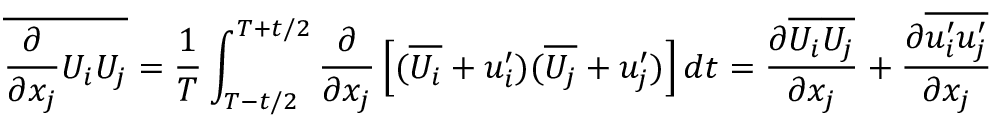Convert formula to latex. <formula><loc_0><loc_0><loc_500><loc_500>\overline { { { \frac { \partial } { \partial x _ { j } } } U _ { i } U _ { j } } } = { \frac { 1 } { T } } \int _ { T - t / 2 } ^ { T + t / 2 } { \frac { \partial } { \partial x _ { j } } } \left [ ( \overline { { U _ { i } } } + u _ { i } ^ { \prime } ) ( \overline { { U _ { j } } } + u _ { j } ^ { \prime } ) \right ] d t = { \frac { \partial \overline { { U _ { i } } } \overline { { U _ { j } } } } { \partial x _ { j } } } + { \frac { \partial \overline { { u _ { i } ^ { \prime } u _ { j } ^ { \prime } } } } { \partial x _ { j } } }</formula> 